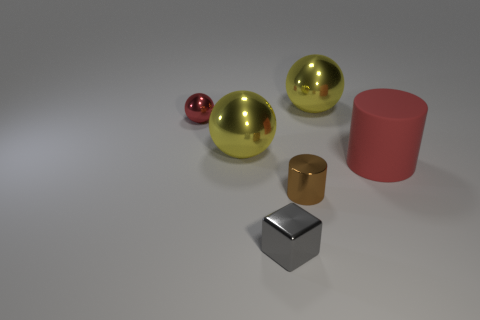Are there more shiny blocks than large yellow metal objects?
Offer a terse response. No. There is a small brown thing that is the same shape as the large red thing; what is it made of?
Offer a terse response. Metal. Does the tiny gray thing have the same material as the red sphere?
Your answer should be very brief. Yes. Is the number of spheres on the right side of the small gray shiny thing greater than the number of cyan blocks?
Provide a short and direct response. Yes. The big thing right of the large yellow ball that is behind the red object to the left of the big red matte cylinder is made of what material?
Ensure brevity in your answer.  Rubber. What number of things are either red rubber cylinders or things that are right of the red metallic object?
Offer a very short reply. 5. Do the tiny object behind the large red matte cylinder and the rubber thing have the same color?
Ensure brevity in your answer.  Yes. Is the number of tiny shiny cubes left of the tiny metal cylinder greater than the number of shiny cylinders on the left side of the gray cube?
Keep it short and to the point. Yes. Is there any other thing of the same color as the block?
Offer a very short reply. No. What number of objects are tiny purple matte blocks or big red matte cylinders?
Give a very brief answer. 1. 